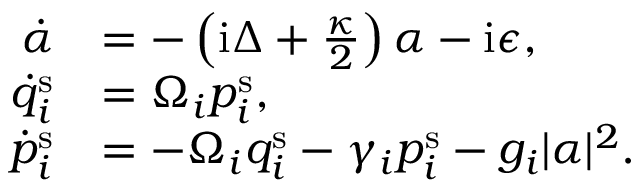Convert formula to latex. <formula><loc_0><loc_0><loc_500><loc_500>\begin{array} { r l } { \dot { \alpha } } & { = - \left ( i \Delta + \frac { \kappa } { 2 } \right ) \alpha - i \epsilon , } \\ { \dot { q } _ { i } ^ { s } } & { = \Omega _ { i } p _ { i } ^ { s } , } \\ { \dot { p } _ { i } ^ { s } } & { = - \Omega _ { i } q _ { i } ^ { s } - \gamma _ { i } p _ { i } ^ { s } - g _ { i } | \alpha | ^ { 2 } . } \end{array}</formula> 